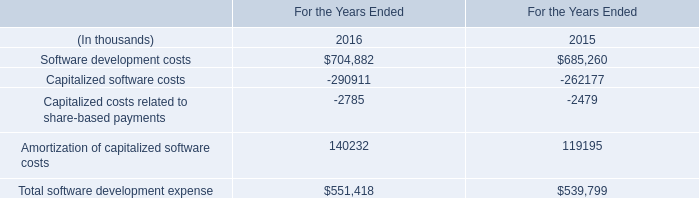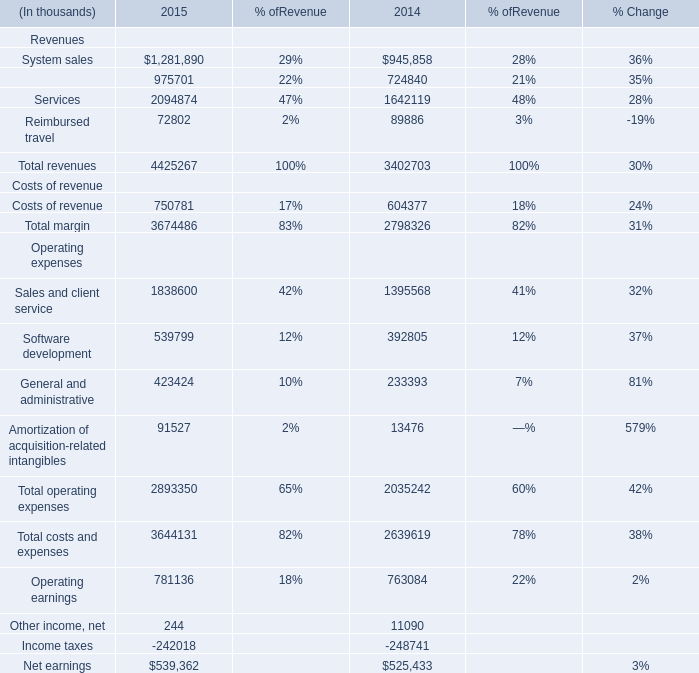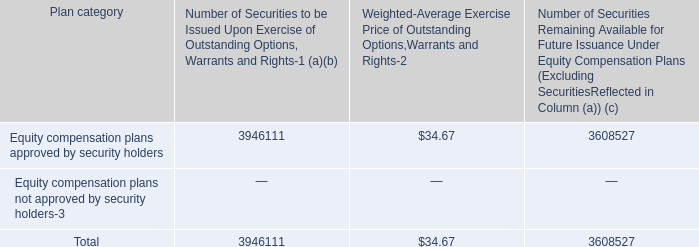What's the total amount of the Net earnings in the year where Total revenues is greater than 4400000 thousand? (in thousand) 
Answer: 539362. 